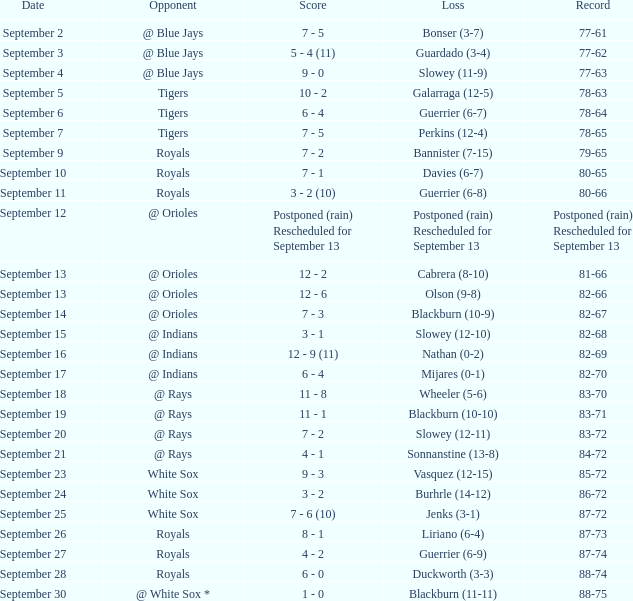On which date was the record of 77-62 achieved? September 3. 